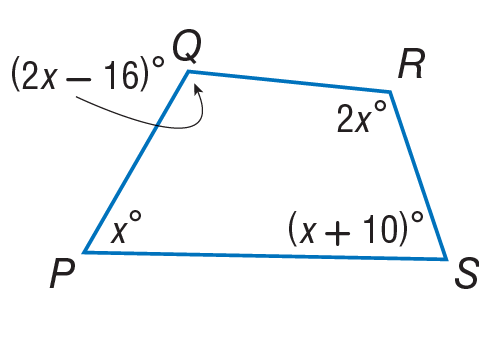Question: Find the measure of \angle P.
Choices:
A. 61
B. 71
C. 106
D. 122
Answer with the letter. Answer: A Question: Find the measure of \angle R.
Choices:
A. 5
B. 40
C. 78
D. 122
Answer with the letter. Answer: D Question: Find the measure of \angle S.
Choices:
A. 71
B. 128
C. 142
D. 152
Answer with the letter. Answer: A 